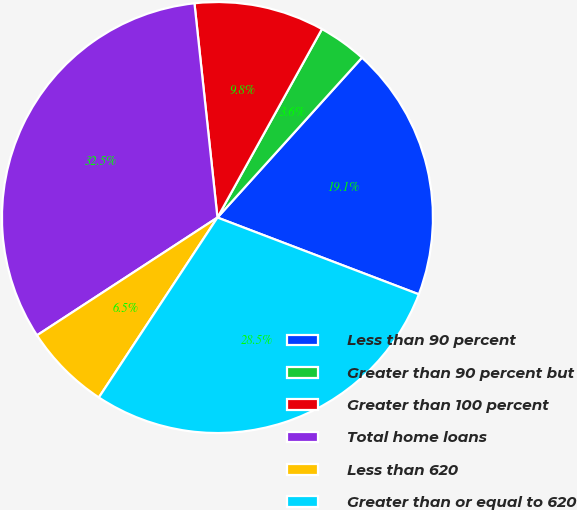<chart> <loc_0><loc_0><loc_500><loc_500><pie_chart><fcel>Less than 90 percent<fcel>Greater than 90 percent but<fcel>Greater than 100 percent<fcel>Total home loans<fcel>Less than 620<fcel>Greater than or equal to 620<nl><fcel>19.1%<fcel>3.64%<fcel>9.76%<fcel>32.5%<fcel>6.52%<fcel>28.48%<nl></chart> 